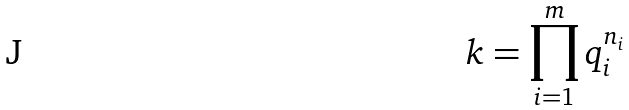<formula> <loc_0><loc_0><loc_500><loc_500>k = \prod _ { i = 1 } ^ { m } q _ { i } ^ { n _ { i } }</formula> 